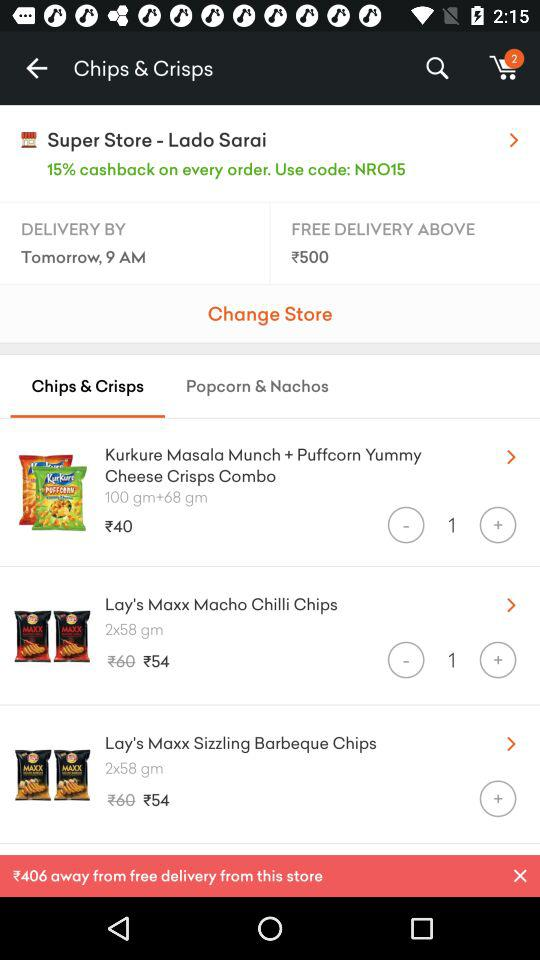When will the delivery be done? The delivery will be done by tomorrow at 9 a.m. 